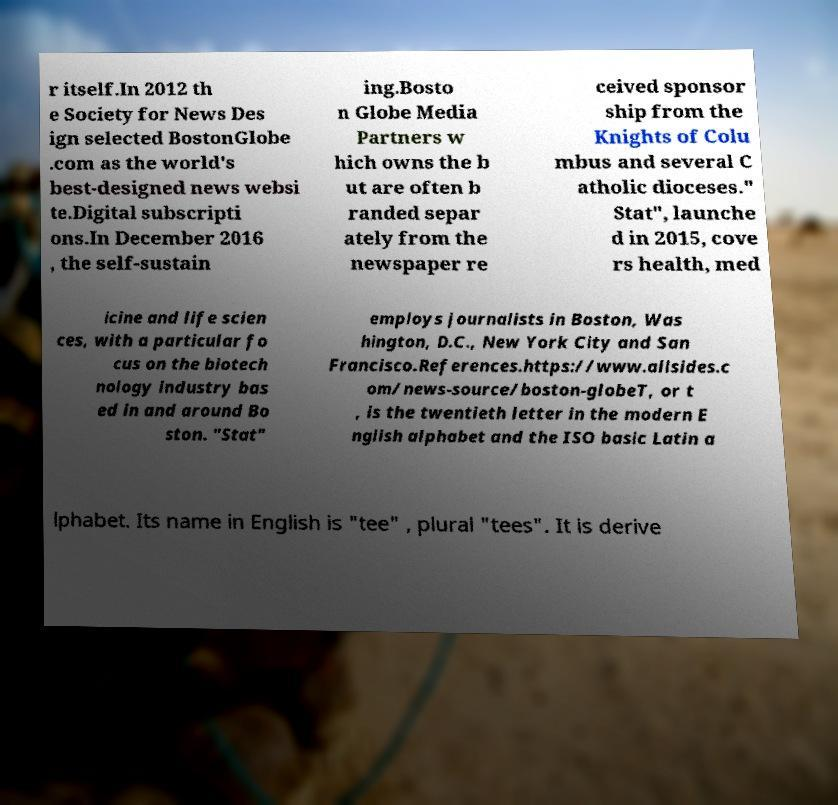Could you extract and type out the text from this image? r itself.In 2012 th e Society for News Des ign selected BostonGlobe .com as the world's best-designed news websi te.Digital subscripti ons.In December 2016 , the self-sustain ing.Bosto n Globe Media Partners w hich owns the b ut are often b randed separ ately from the newspaper re ceived sponsor ship from the Knights of Colu mbus and several C atholic dioceses." Stat", launche d in 2015, cove rs health, med icine and life scien ces, with a particular fo cus on the biotech nology industry bas ed in and around Bo ston. "Stat" employs journalists in Boston, Was hington, D.C., New York City and San Francisco.References.https://www.allsides.c om/news-source/boston-globeT, or t , is the twentieth letter in the modern E nglish alphabet and the ISO basic Latin a lphabet. Its name in English is "tee" , plural "tees". It is derive 